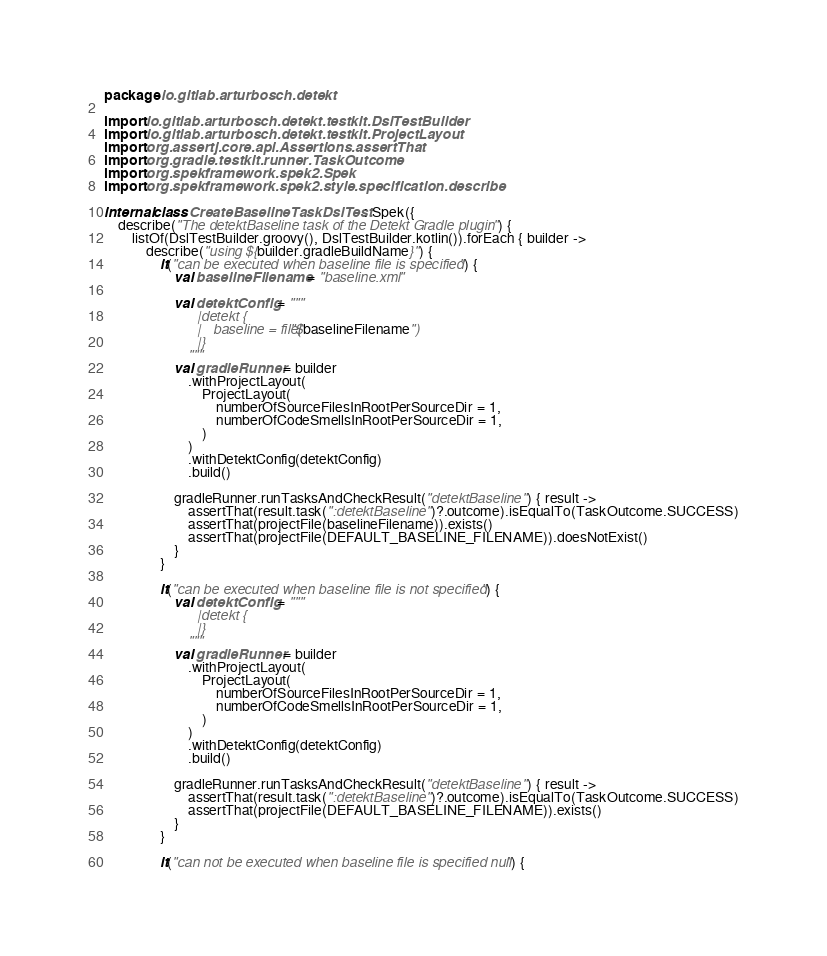<code> <loc_0><loc_0><loc_500><loc_500><_Kotlin_>package io.gitlab.arturbosch.detekt

import io.gitlab.arturbosch.detekt.testkit.DslTestBuilder
import io.gitlab.arturbosch.detekt.testkit.ProjectLayout
import org.assertj.core.api.Assertions.assertThat
import org.gradle.testkit.runner.TaskOutcome
import org.spekframework.spek2.Spek
import org.spekframework.spek2.style.specification.describe

internal class CreateBaselineTaskDslTest : Spek({
    describe("The detektBaseline task of the Detekt Gradle plugin") {
        listOf(DslTestBuilder.groovy(), DslTestBuilder.kotlin()).forEach { builder ->
            describe("using ${builder.gradleBuildName}") {
                it("can be executed when baseline file is specified") {
                    val baselineFilename = "baseline.xml"

                    val detektConfig = """
                        |detekt {
                        |   baseline = file("$baselineFilename")
                        |}
                        """
                    val gradleRunner = builder
                        .withProjectLayout(
                            ProjectLayout(
                                numberOfSourceFilesInRootPerSourceDir = 1,
                                numberOfCodeSmellsInRootPerSourceDir = 1,
                            )
                        )
                        .withDetektConfig(detektConfig)
                        .build()

                    gradleRunner.runTasksAndCheckResult("detektBaseline") { result ->
                        assertThat(result.task(":detektBaseline")?.outcome).isEqualTo(TaskOutcome.SUCCESS)
                        assertThat(projectFile(baselineFilename)).exists()
                        assertThat(projectFile(DEFAULT_BASELINE_FILENAME)).doesNotExist()
                    }
                }

                it("can be executed when baseline file is not specified") {
                    val detektConfig = """
                        |detekt {
                        |}
                        """
                    val gradleRunner = builder
                        .withProjectLayout(
                            ProjectLayout(
                                numberOfSourceFilesInRootPerSourceDir = 1,
                                numberOfCodeSmellsInRootPerSourceDir = 1,
                            )
                        )
                        .withDetektConfig(detektConfig)
                        .build()

                    gradleRunner.runTasksAndCheckResult("detektBaseline") { result ->
                        assertThat(result.task(":detektBaseline")?.outcome).isEqualTo(TaskOutcome.SUCCESS)
                        assertThat(projectFile(DEFAULT_BASELINE_FILENAME)).exists()
                    }
                }

                it("can not be executed when baseline file is specified null") {</code> 